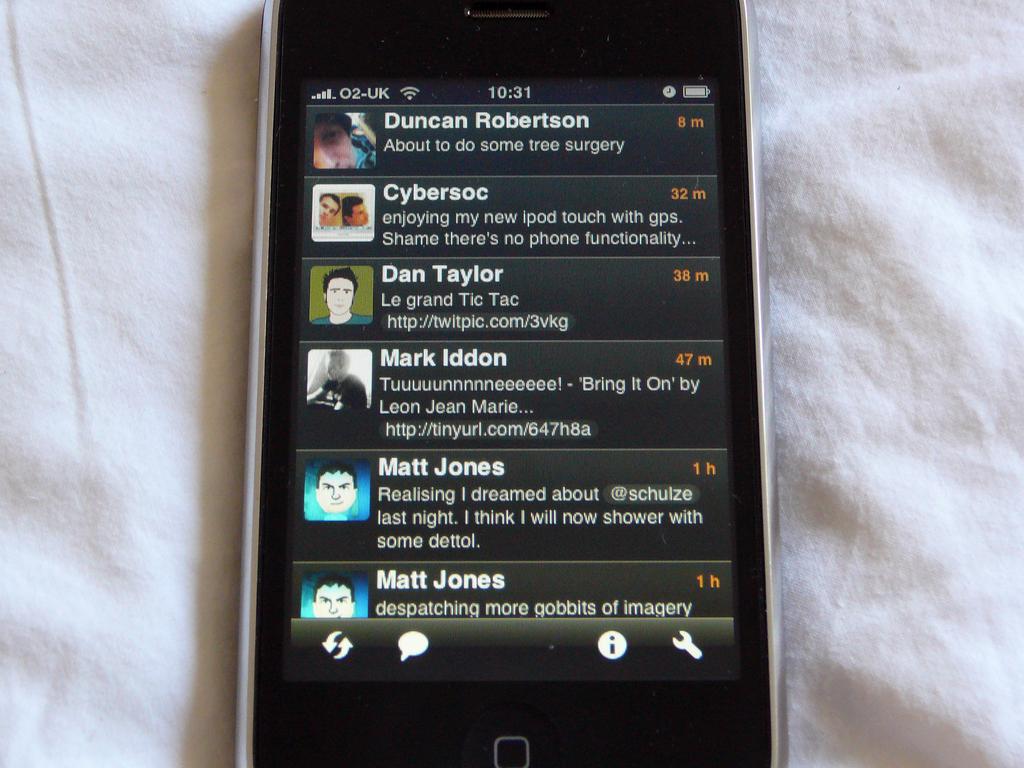What is duncan robertson about to do?
Make the answer very short. Tree surgery. Whos name is to the very bottom of the smartphone screen?
Keep it short and to the point. Matt jones. 